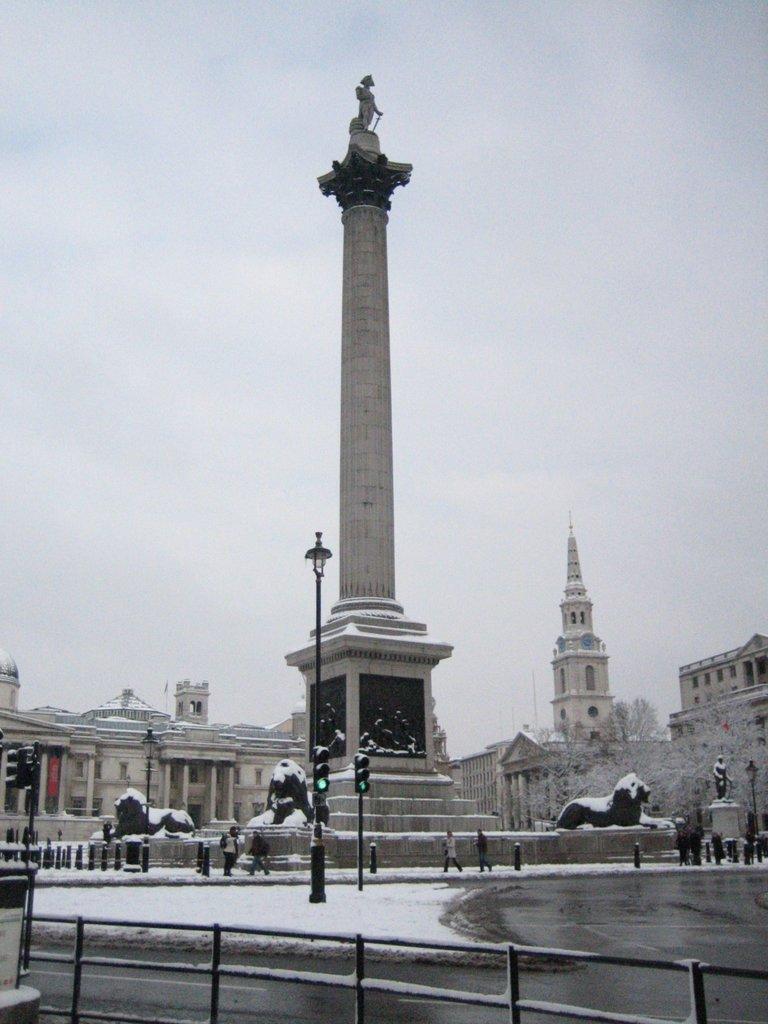Please provide a concise description of this image. In this image I can see roads and on it I can see snow. I can also see few poles, few signal lights, a street light and in the background. I can see number of buildings, trees, sculptures and I can see few people are standing. Here I can see railing and I can also see one more sculpture over here. 